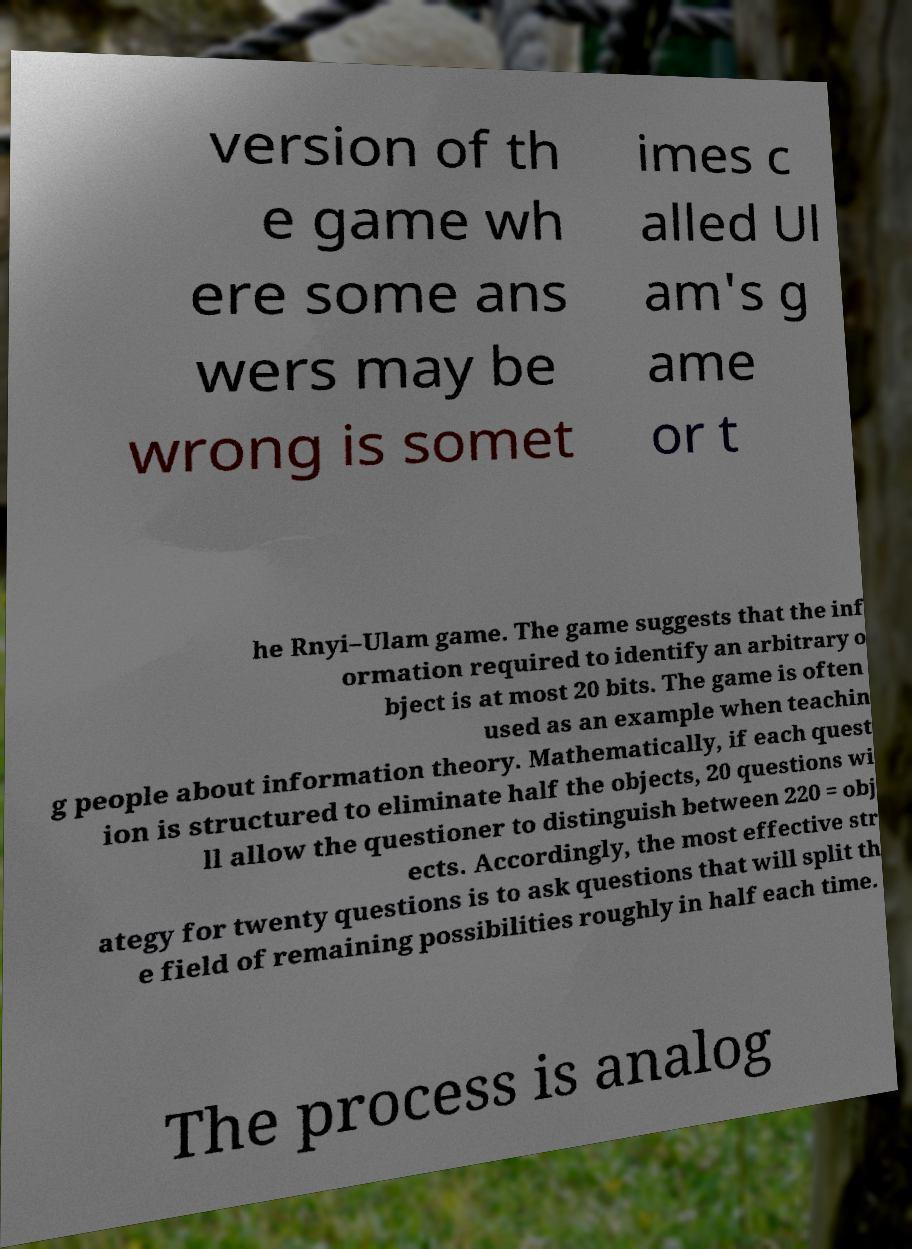There's text embedded in this image that I need extracted. Can you transcribe it verbatim? version of th e game wh ere some ans wers may be wrong is somet imes c alled Ul am's g ame or t he Rnyi–Ulam game. The game suggests that the inf ormation required to identify an arbitrary o bject is at most 20 bits. The game is often used as an example when teachin g people about information theory. Mathematically, if each quest ion is structured to eliminate half the objects, 20 questions wi ll allow the questioner to distinguish between 220 = obj ects. Accordingly, the most effective str ategy for twenty questions is to ask questions that will split th e field of remaining possibilities roughly in half each time. The process is analog 